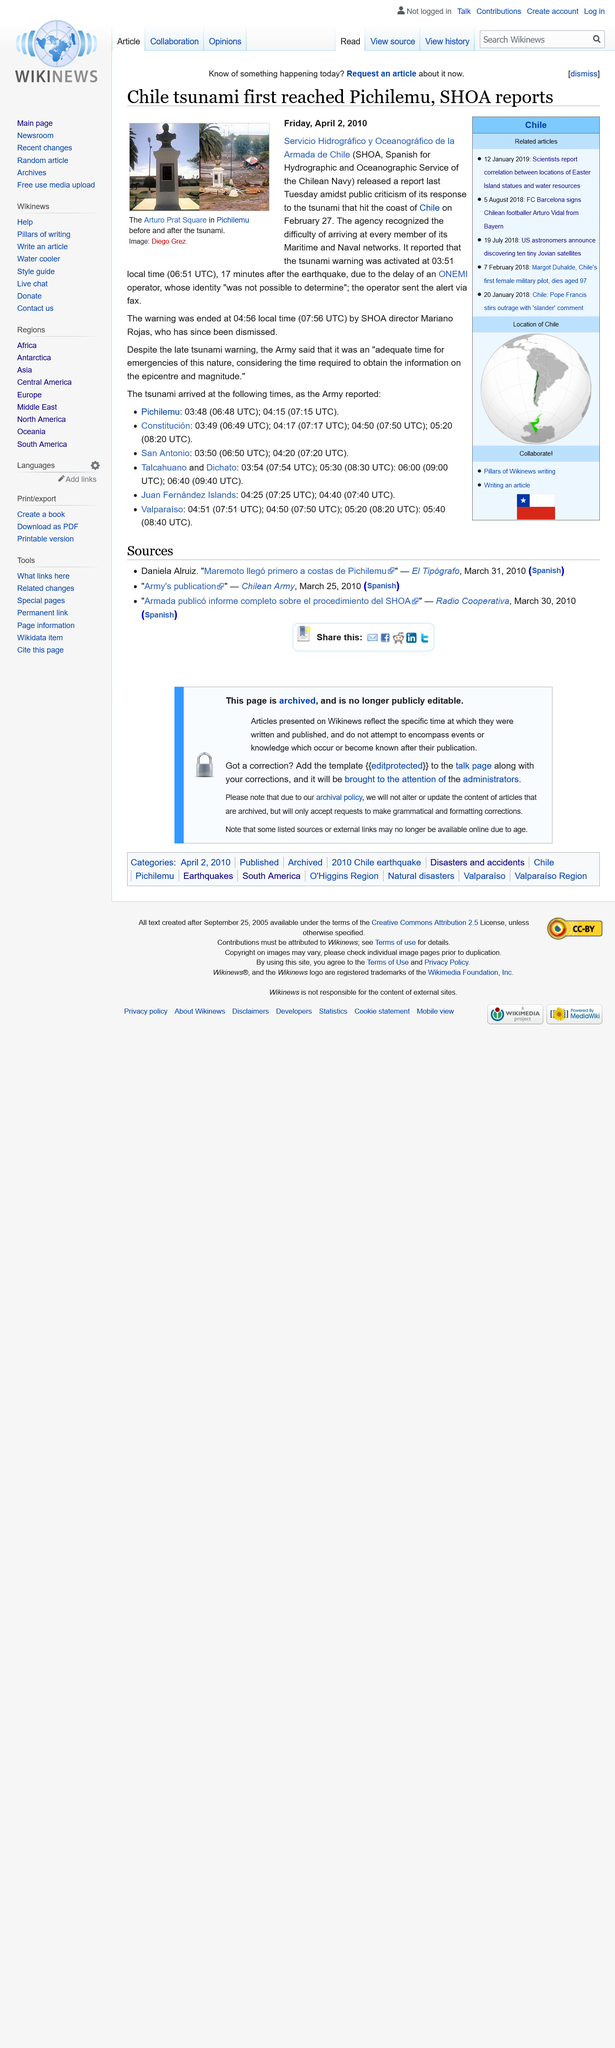Give some essential details in this illustration. After the earthquake in Chile, the director of SHOA, Mariano Rojas, was dismissed from his position. On February 27, 2010, a tsunami hit the coast of Chile. The Chile tsunami warning was activated at 03:51. 